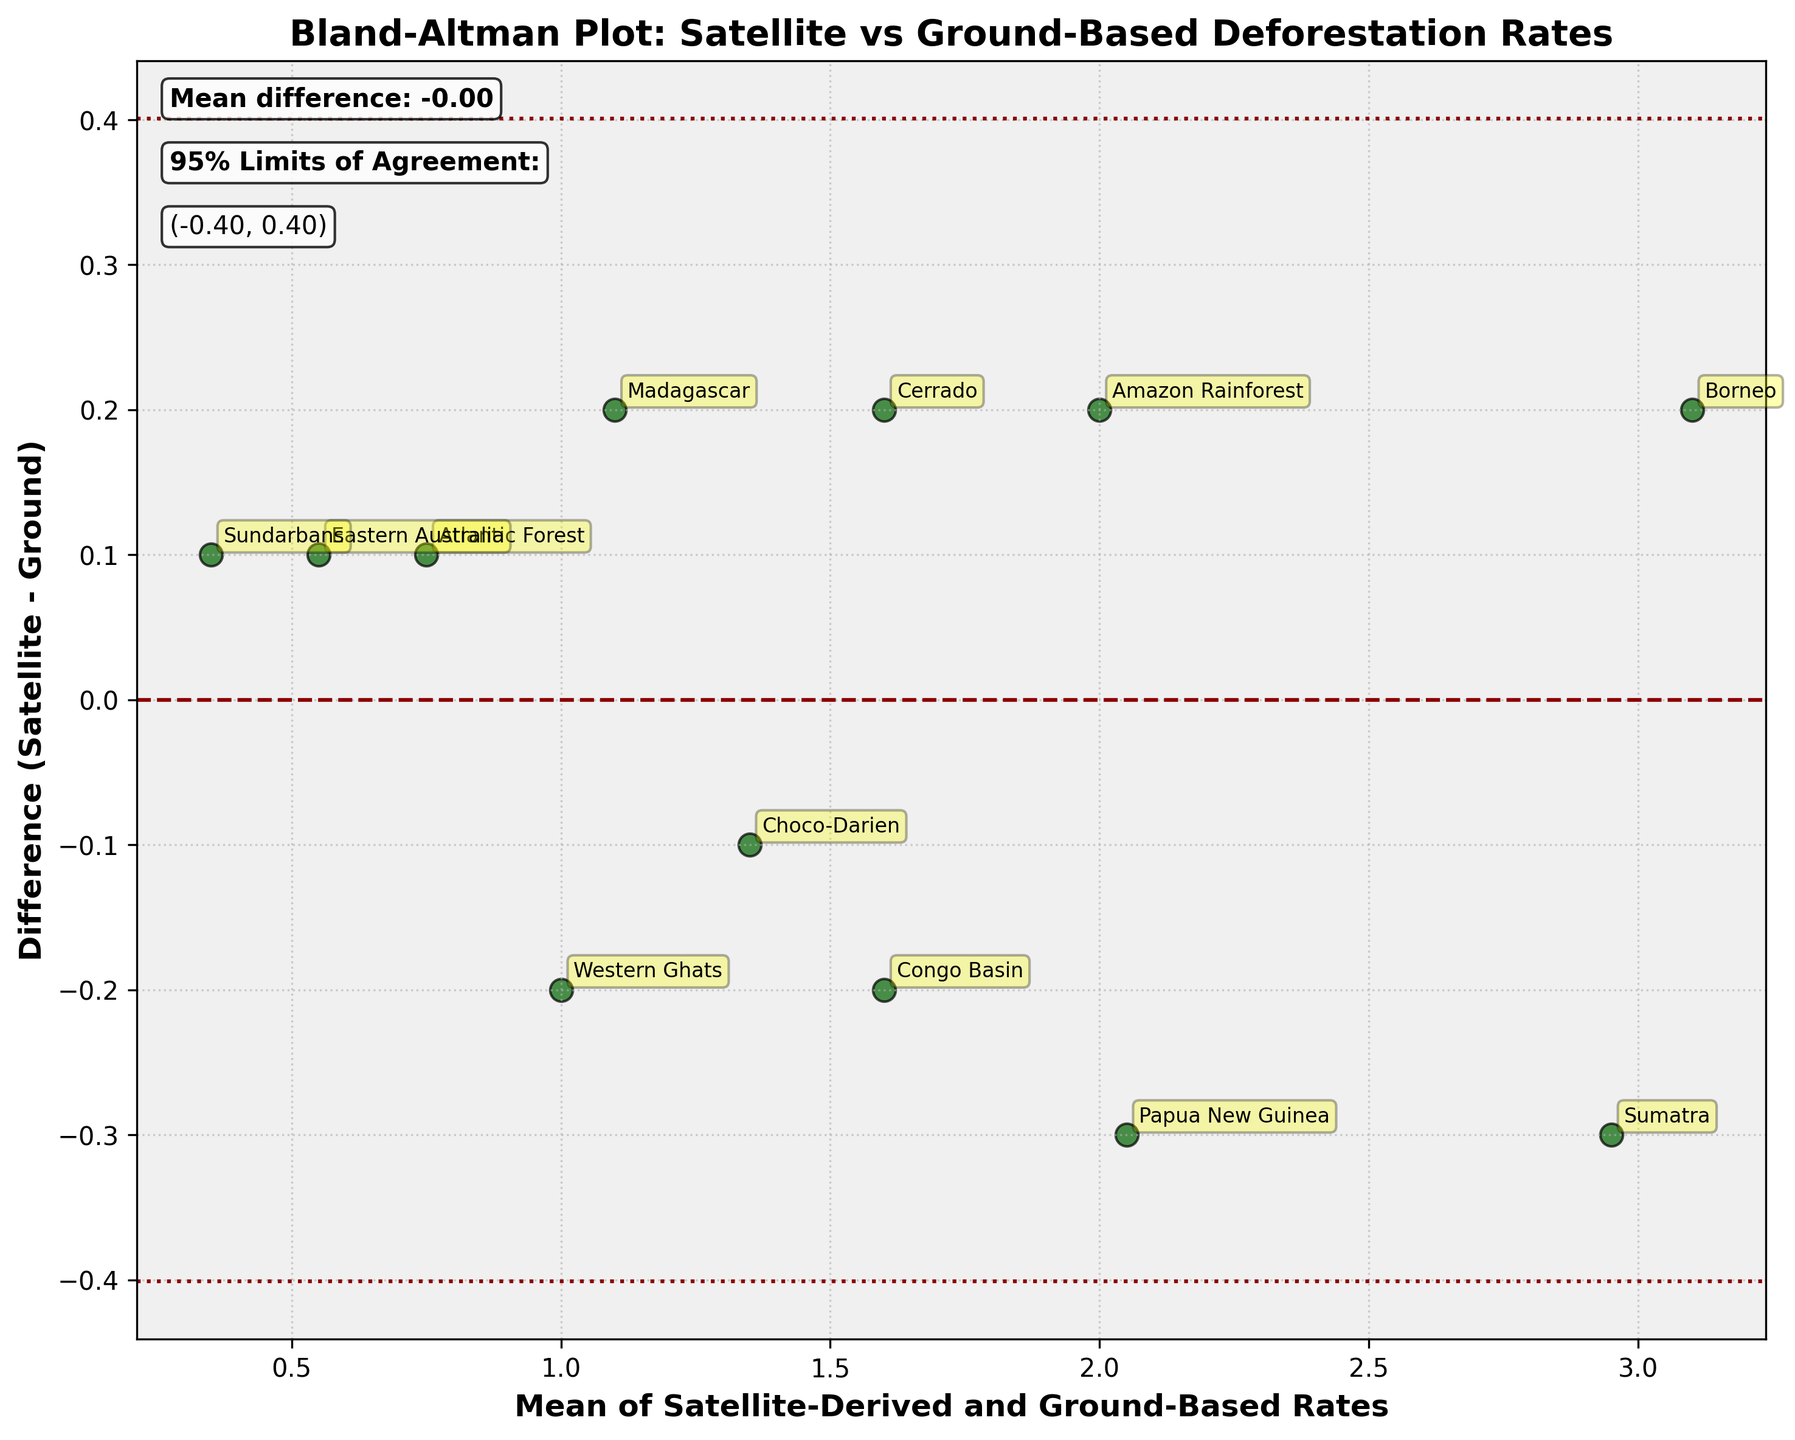What is the title of the plot? The title of the plot is located at the top of the figure. It reads, "Bland-Altman Plot: Satellite vs Ground-Based Deforestation Rates".
Answer: Bland-Altman Plot: Satellite vs Ground-Based Deforestation Rates What does the x-axis represent in the plot? The x-axis label is at the bottom of the plot, and it reads "Mean of Satellite-Derived and Ground-Based Rates". This indicates that the x-axis represents the average of both satellite-derived and ground-based deforestation rates for each method.
Answer: Mean of Satellite-Derived and Ground-Based Rates What are the differences plotted along the y-axis? The y-axis label reads "Difference (Satellite - Ground)", indicating that the y-axis represents the difference between the satellite-derived deforestation rates and the ground-based rates for each method.
Answer: Difference (Satellite - Ground) How many data points are plotted in the figure? Each method has a corresponding data point on the plot. There are 12 methods shown in the sample data (Amazon Rainforest, Congo Basin, etc.), which means there are 12 data points plotted.
Answer: 12 Which method has the largest positive difference between satellite-derived and ground-based rates? Observe the data points above the zero line on the y-axis. "Borneo" is the point with the highest value above the zero line, indicating the largest positive difference.
Answer: Borneo What is the mean difference, and how is it represented on the plot? The mean difference is calculated and drawn as a dashed horizontal line across the plot. In the plot, it is visually indicated as a line near 0 on the y-axis, and the text box on the plot mentions "Mean difference: 0.02".
Answer: 0.02 What are the 95% limits of agreement, and how are they represented on the plot? The 95% limits of agreement are determined by the mean difference ± 1.96 times the standard deviation of the differences. These limits are represented by dotted horizontal lines on the plot, and the text boxes mention the values as (-0.64, 0.68).
Answer: (-0.64, 0.68) Which methods have differences outside the 95% limits of agreement? Look for points that fall outside the dotted horizontal lines indicating the limits of agreement. No points are outside these limits in this plot, implying all differences fall within the 95% limits.
Answer: None Are there more methods with positive or negative differences? Count the number of points above and below the zero line on the y-axis. There are more points, and therefore methods, below the zero line, indicating more negative differences.
Answer: Negative differences What's the difference for the "Eastern Australia" data point? Locate the "Eastern Australia" annotation on the plot, which is near the bottom right. The y-coordinate of this point corresponds to the difference, which is -0.1.
Answer: -0.1 